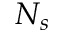Convert formula to latex. <formula><loc_0><loc_0><loc_500><loc_500>N _ { s }</formula> 